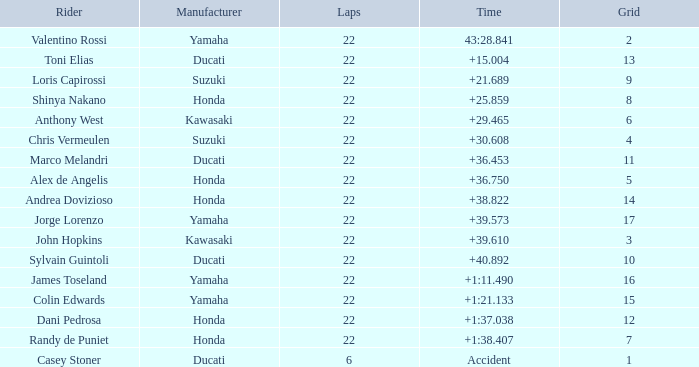What is Honda's highest grid with a time of +1:38.407? 7.0. 